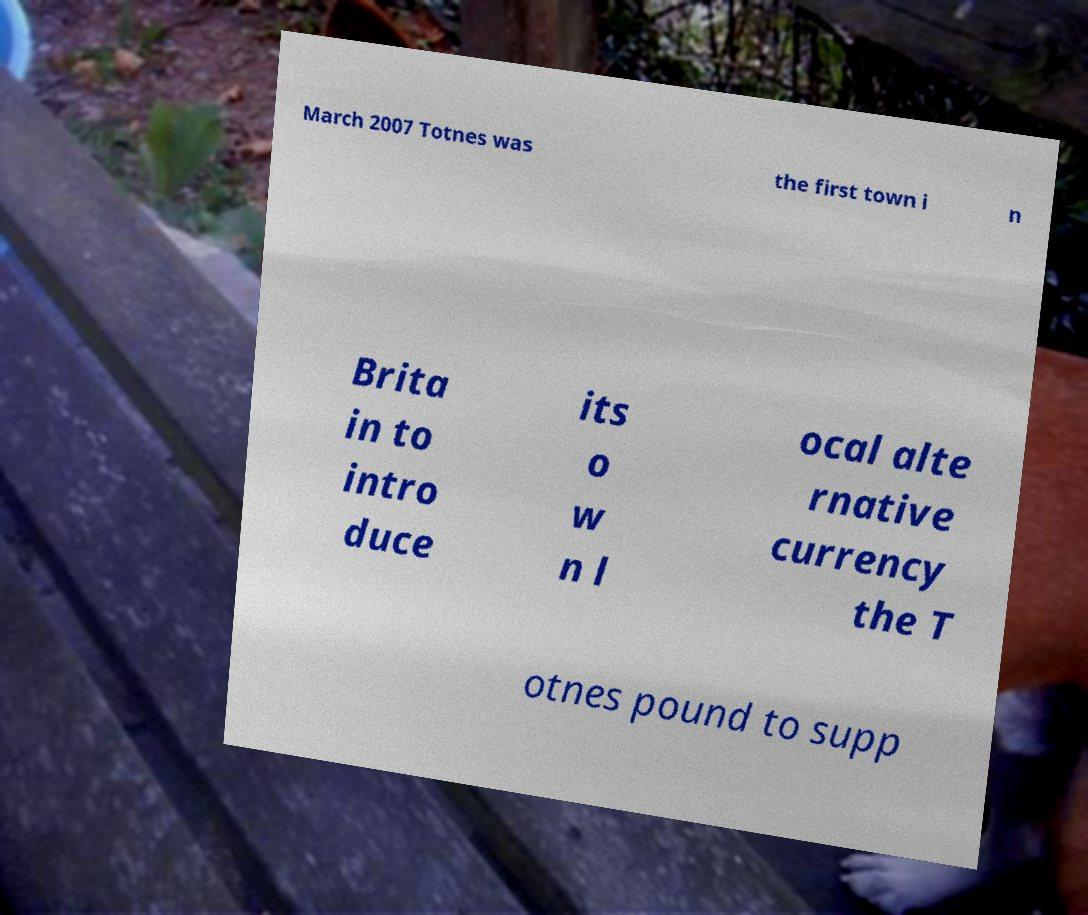There's text embedded in this image that I need extracted. Can you transcribe it verbatim? March 2007 Totnes was the first town i n Brita in to intro duce its o w n l ocal alte rnative currency the T otnes pound to supp 